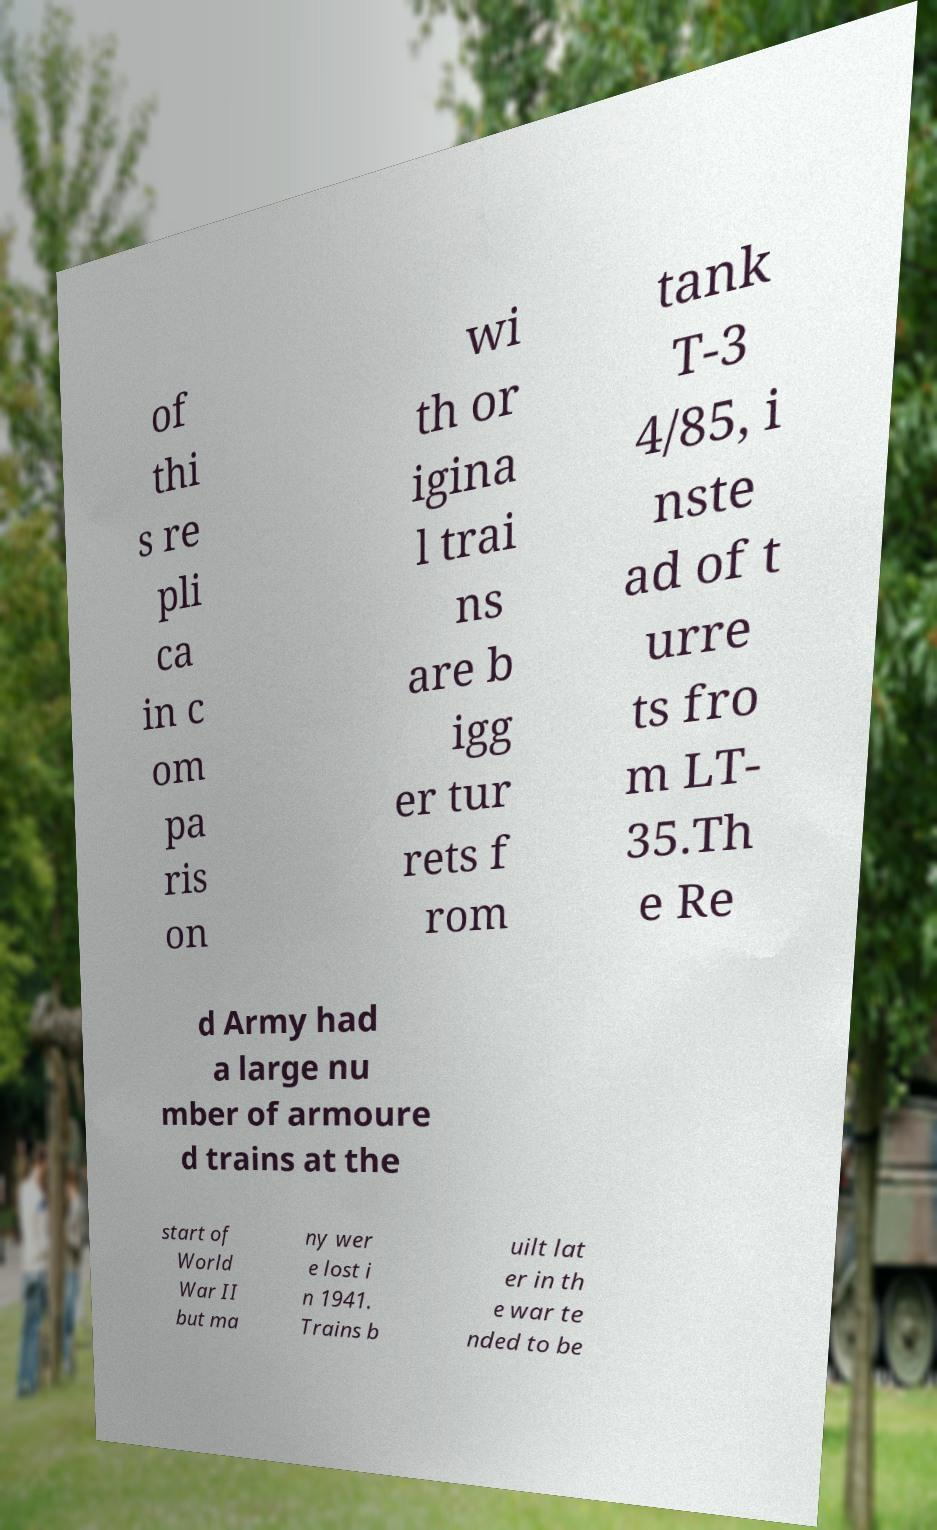Please read and relay the text visible in this image. What does it say? of thi s re pli ca in c om pa ris on wi th or igina l trai ns are b igg er tur rets f rom tank T-3 4/85, i nste ad of t urre ts fro m LT- 35.Th e Re d Army had a large nu mber of armoure d trains at the start of World War II but ma ny wer e lost i n 1941. Trains b uilt lat er in th e war te nded to be 